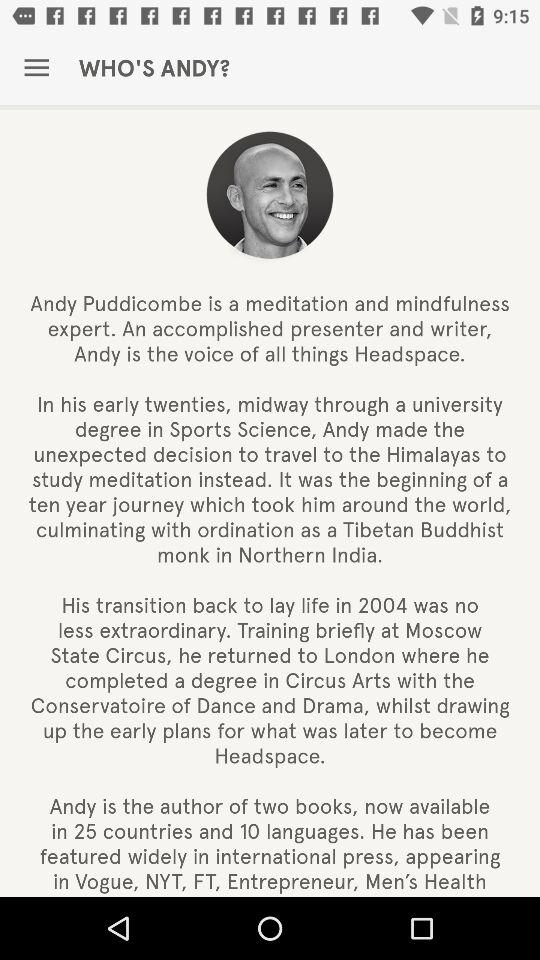What is the total number of countries and languages in which Andy's books are available?
Answer the question using a single word or phrase. 35 